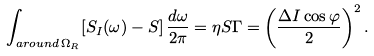Convert formula to latex. <formula><loc_0><loc_0><loc_500><loc_500>\int _ { a r o u n d \, \Omega _ { R } } [ S _ { I } ( \omega ) - S ] \, \frac { d \omega } { 2 \pi } = \eta S \Gamma = \left ( \frac { \Delta I \cos \varphi } { 2 } \right ) ^ { 2 } .</formula> 